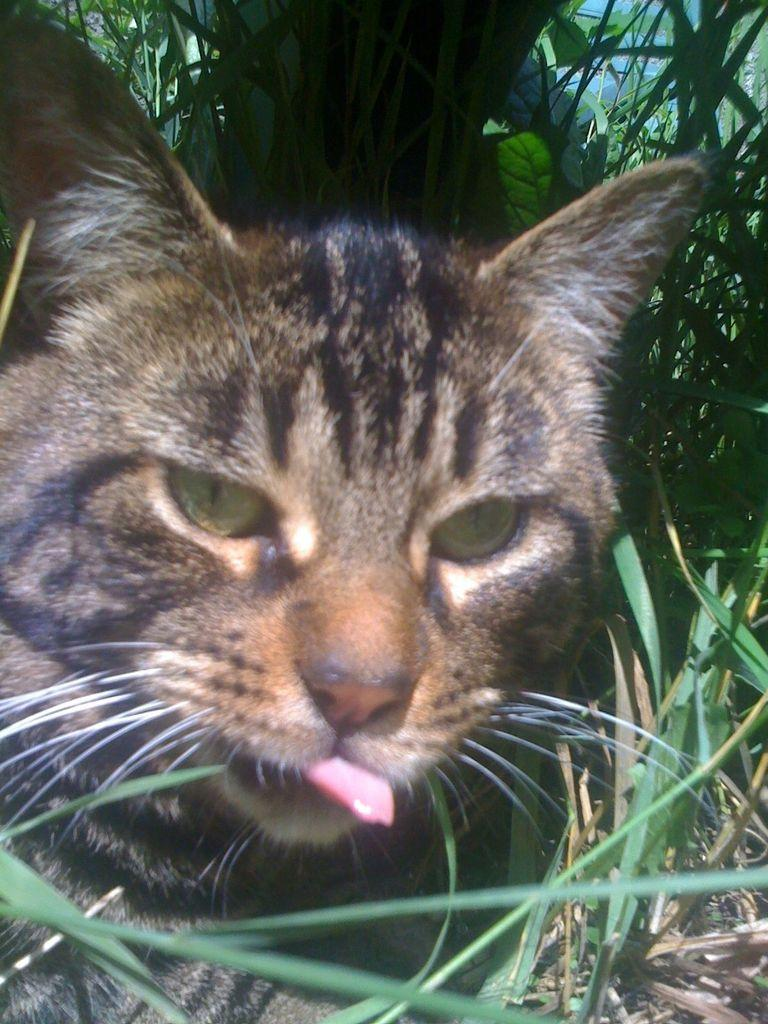What type of animal is in the image? There is a cat in the image. Where is the cat located in the image? The cat is on the ground. What type of vegetation is visible in the background of the image? There is grass visible in the background of the image. What type of fruit is the cat holding in the image? There is no fruit, such as a banana, present in the image. Can you tell me how many sons the cat has in the image? Cats do not have sons; they give birth to kittens. However, there is no indication of any offspring in the image. 